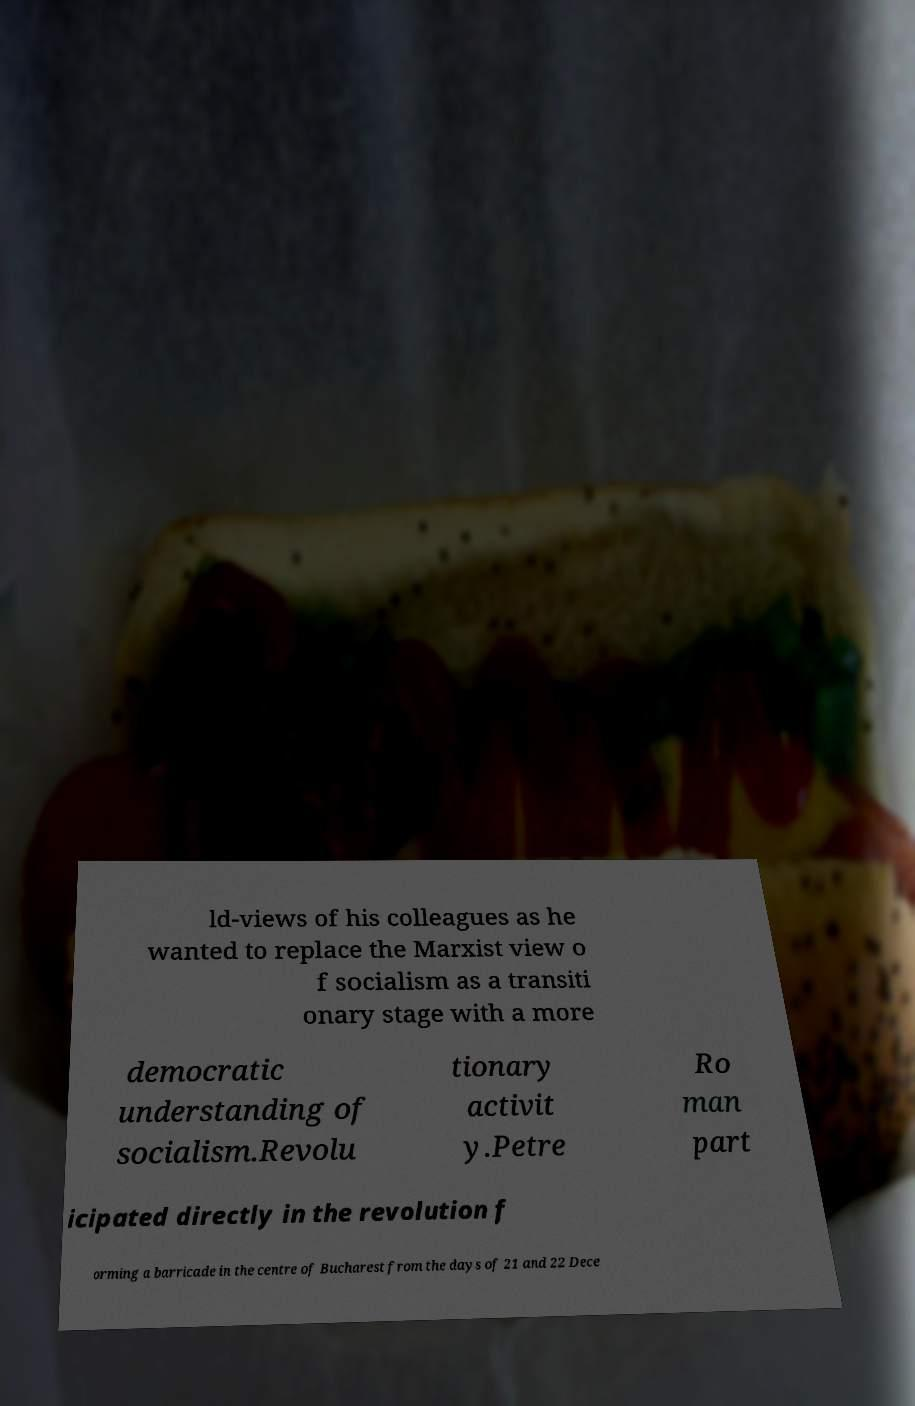I need the written content from this picture converted into text. Can you do that? ld-views of his colleagues as he wanted to replace the Marxist view o f socialism as a transiti onary stage with a more democratic understanding of socialism.Revolu tionary activit y.Petre Ro man part icipated directly in the revolution f orming a barricade in the centre of Bucharest from the days of 21 and 22 Dece 